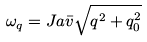Convert formula to latex. <formula><loc_0><loc_0><loc_500><loc_500>\omega _ { q } = J a \bar { v } \sqrt { q ^ { 2 } + q ^ { 2 } _ { 0 } }</formula> 